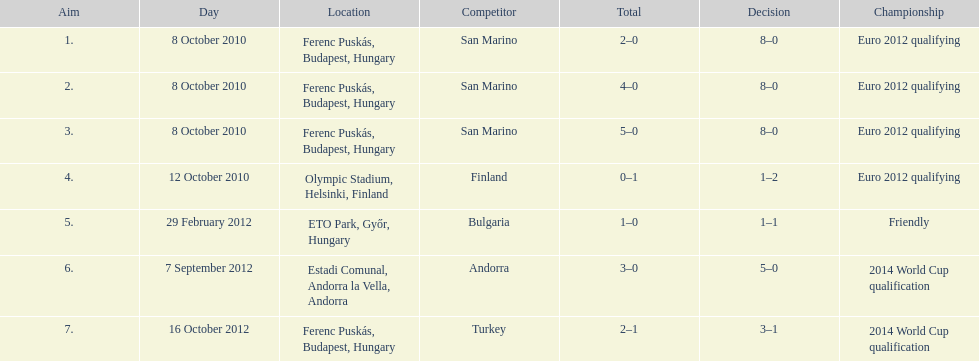When did ádám szalai make his first international goal? 8 October 2010. 